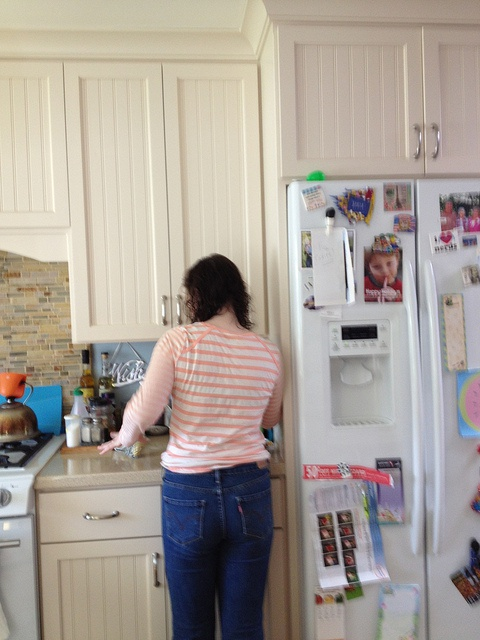Describe the objects in this image and their specific colors. I can see refrigerator in beige, darkgray, lightgray, and gray tones, people in beige, black, lightpink, navy, and darkgray tones, oven in beige, darkgray, lightgray, and gray tones, people in beige, gray, maroon, brown, and darkgray tones, and bottle in beige, black, maroon, and olive tones in this image. 